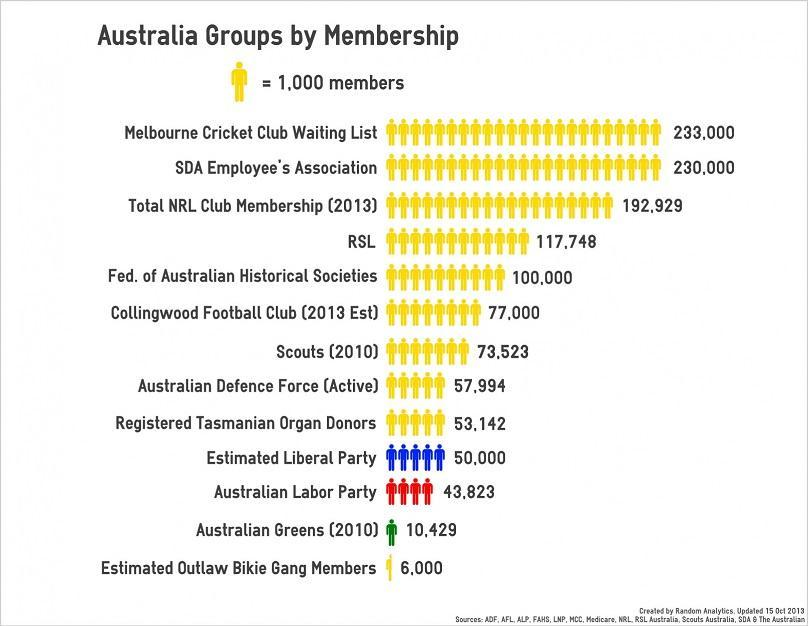Which Australia Group has the second least no of members?
Answer the question with a short phrase. Australian Greens (2010) Which Australia Group has the second largest no of members? SDA Employee's Association What is the color code given to Estimated Liberal Party- yellow, red, blue, black? blue How many groups have members greater than one Lakh fifty thousand? 3 How many are the members of the Australian Labor Party and Estimated Liberal Party taken together? 93,823 What is the color code given to Australian Labor Party- green, red, yellow, black? red How many groups have members below fifty thousand? 3 